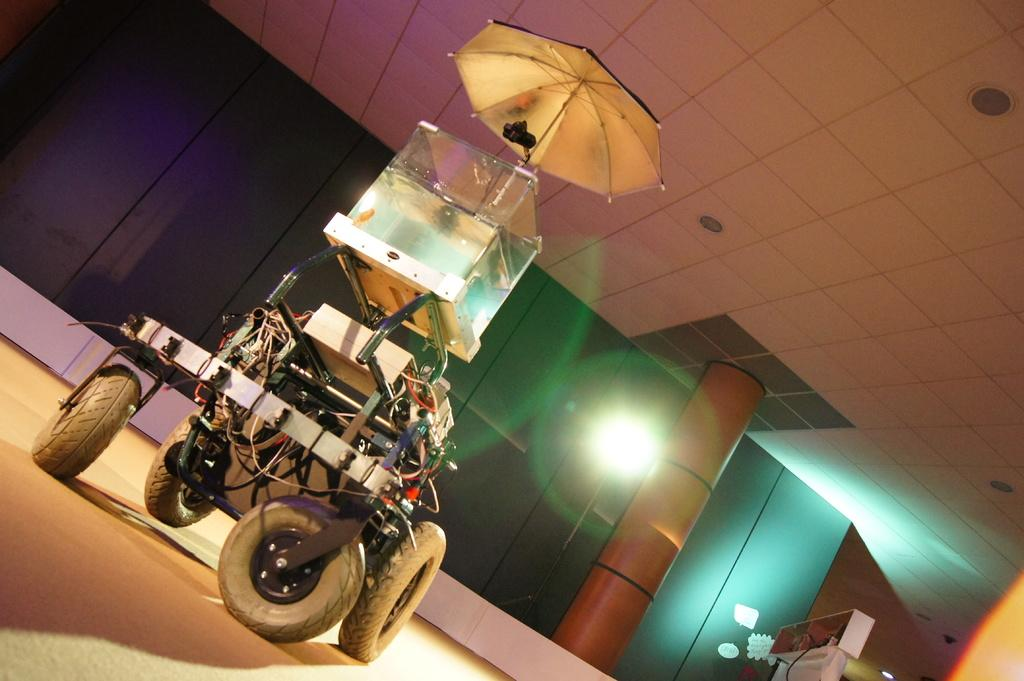What is present in the room that has four wheels? There is a machine in the room that has four wheels. What is positioned above the machine? There is an umbrella above the machine. What colors are the doors in the background? The doors in the background are purple and green. What can be seen in the background that is orange? There is an orange pillar in the background. What time of day is it in the image, and how does the nut contribute to the scene? The time of day cannot be determined from the image, and there is no nut present in the scene. 